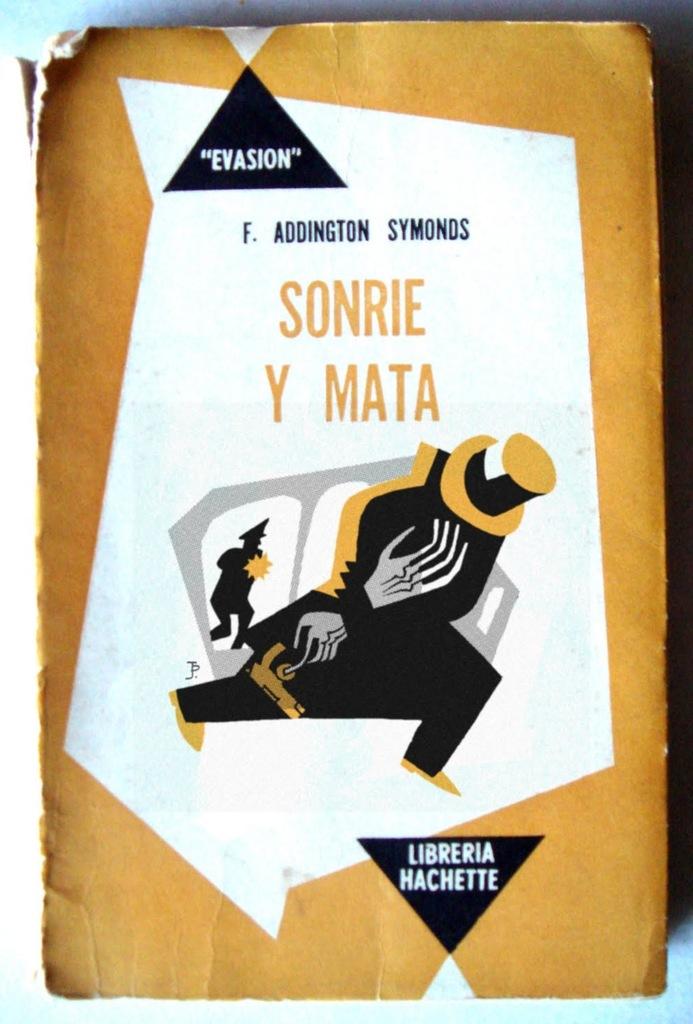What is the book name?
Ensure brevity in your answer.  Sonrie y mata. What is in the black triangle?
Make the answer very short. Evasion. 